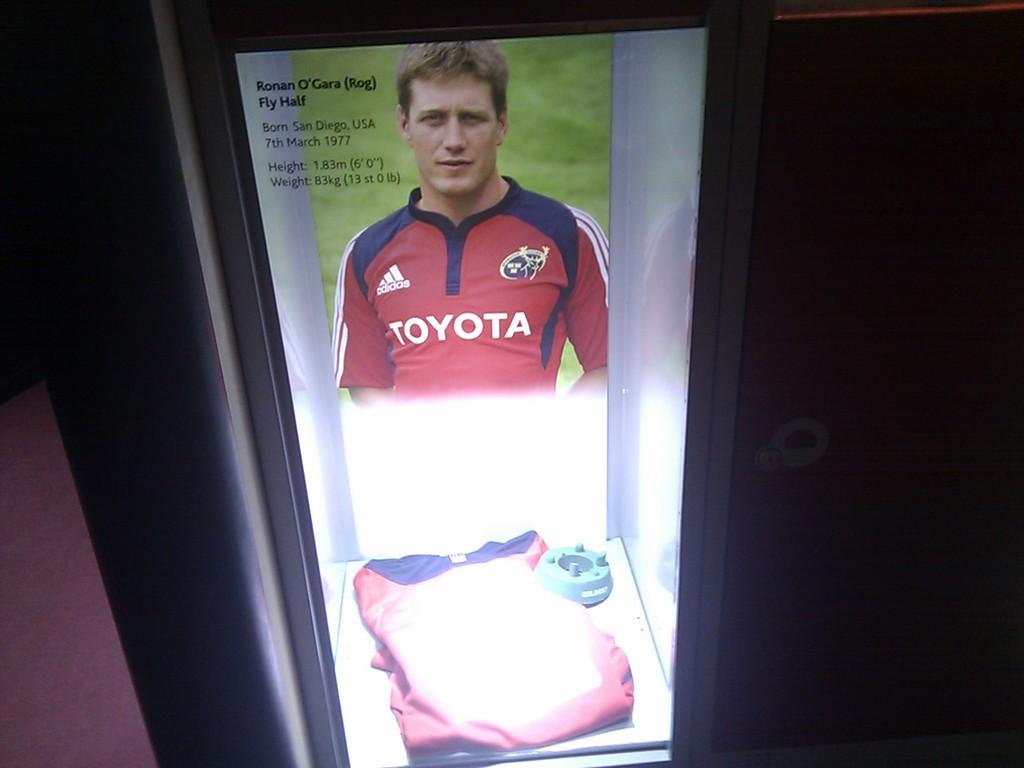Provide a one-sentence caption for the provided image. an ad featuring Ronan O'Gara who was born in San Diego, USA. 